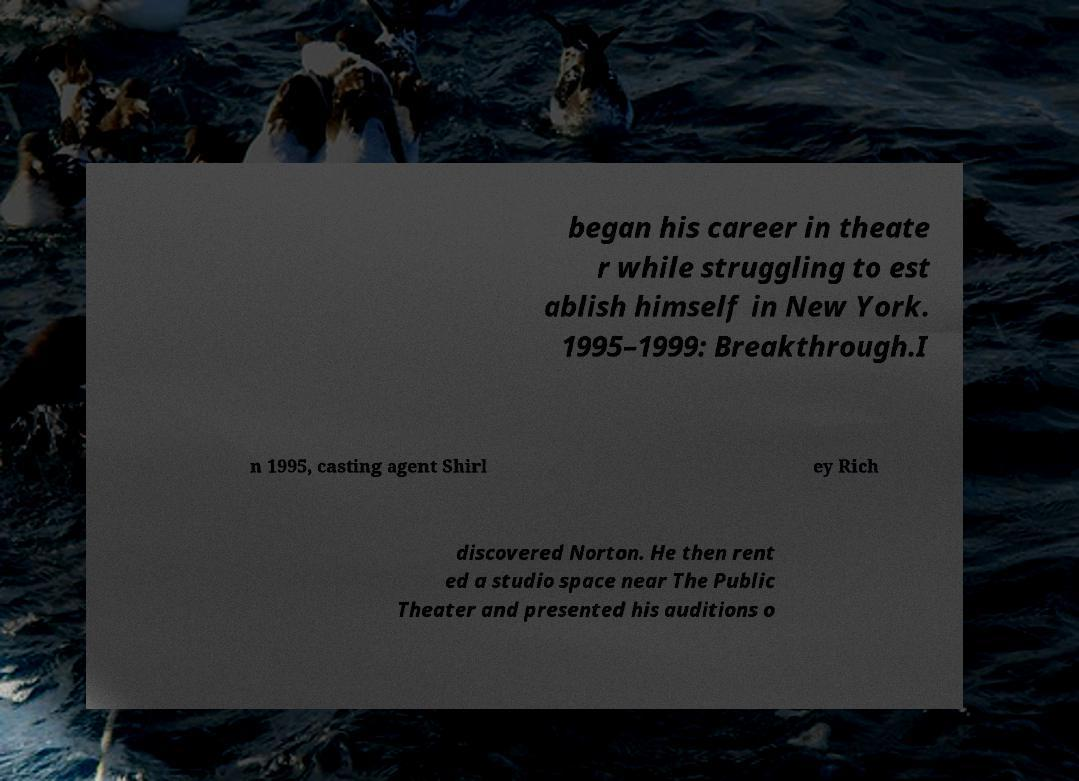Could you extract and type out the text from this image? began his career in theate r while struggling to est ablish himself in New York. 1995–1999: Breakthrough.I n 1995, casting agent Shirl ey Rich discovered Norton. He then rent ed a studio space near The Public Theater and presented his auditions o 